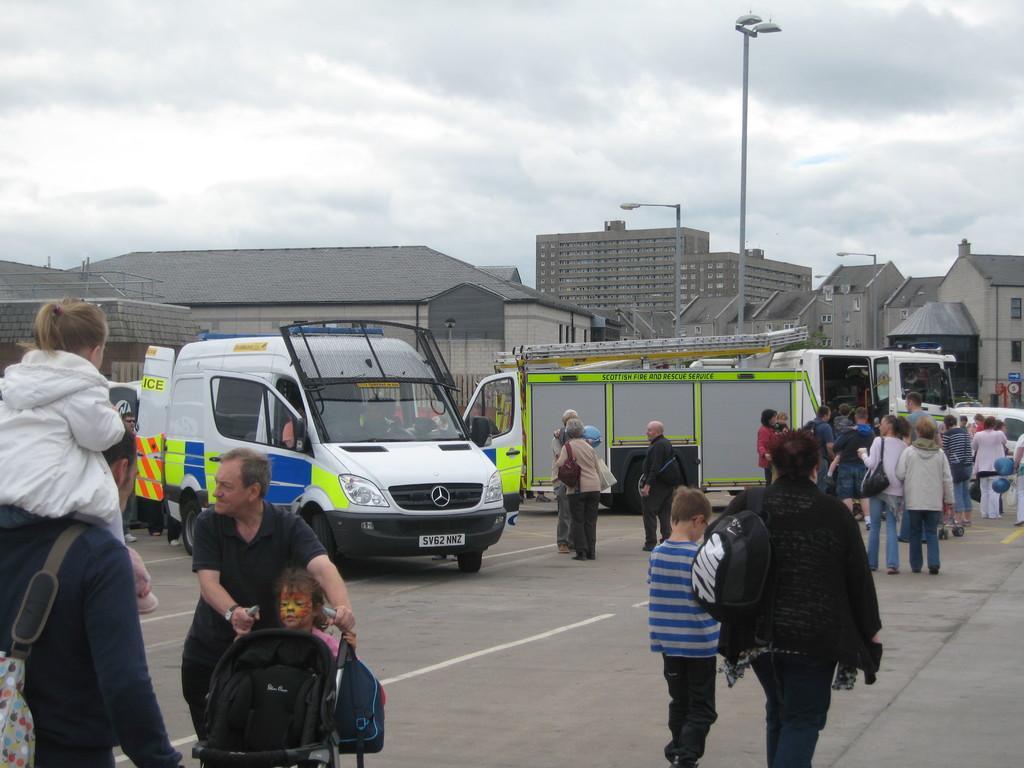Could you give a brief overview of what you see in this image? Here in this picture we can see number of people standing and walking on the road with their children and we can also see vans and trucks present and in the far we can see houses and buildings present and we can also see light posts present and we can see the sky is fully covered with clouds. 